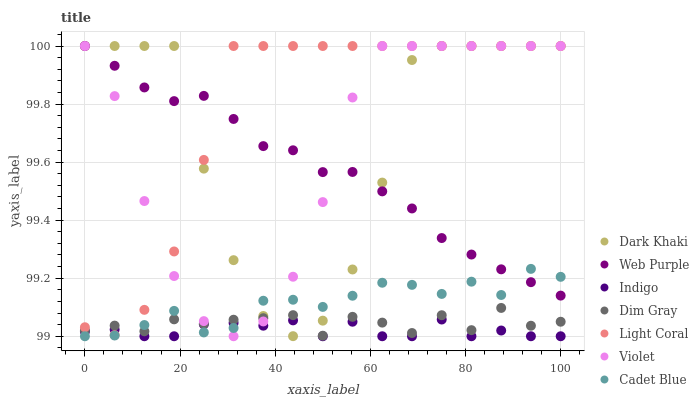Does Indigo have the minimum area under the curve?
Answer yes or no. Yes. Does Light Coral have the maximum area under the curve?
Answer yes or no. Yes. Does Dim Gray have the minimum area under the curve?
Answer yes or no. No. Does Dim Gray have the maximum area under the curve?
Answer yes or no. No. Is Web Purple the smoothest?
Answer yes or no. Yes. Is Dark Khaki the roughest?
Answer yes or no. Yes. Is Dim Gray the smoothest?
Answer yes or no. No. Is Dim Gray the roughest?
Answer yes or no. No. Does Indigo have the lowest value?
Answer yes or no. Yes. Does Dim Gray have the lowest value?
Answer yes or no. No. Does Violet have the highest value?
Answer yes or no. Yes. Does Dim Gray have the highest value?
Answer yes or no. No. Is Indigo less than Dim Gray?
Answer yes or no. Yes. Is Light Coral greater than Cadet Blue?
Answer yes or no. Yes. Does Web Purple intersect Violet?
Answer yes or no. Yes. Is Web Purple less than Violet?
Answer yes or no. No. Is Web Purple greater than Violet?
Answer yes or no. No. Does Indigo intersect Dim Gray?
Answer yes or no. No. 